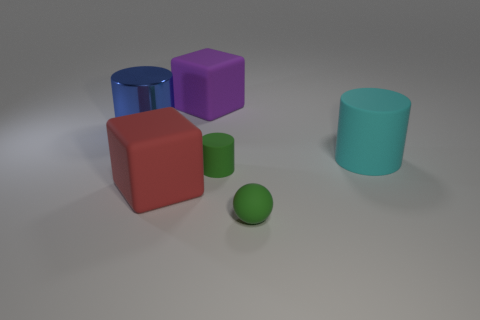Add 2 green cylinders. How many objects exist? 8 Subtract all blocks. How many objects are left? 4 Add 1 small cylinders. How many small cylinders exist? 2 Subtract 1 green spheres. How many objects are left? 5 Subtract all small blue matte cylinders. Subtract all red blocks. How many objects are left? 5 Add 2 metallic objects. How many metallic objects are left? 3 